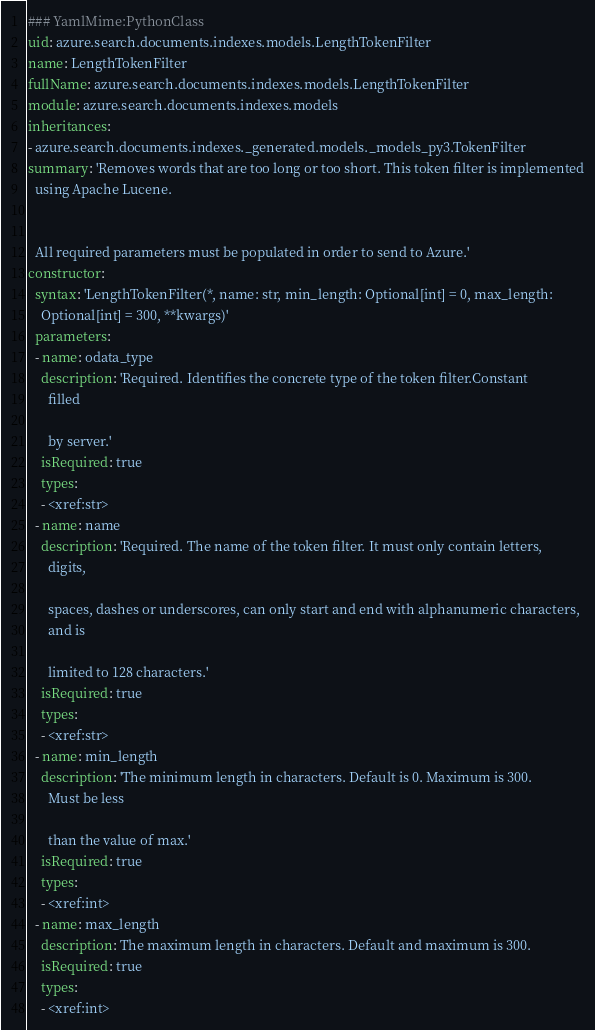Convert code to text. <code><loc_0><loc_0><loc_500><loc_500><_YAML_>### YamlMime:PythonClass
uid: azure.search.documents.indexes.models.LengthTokenFilter
name: LengthTokenFilter
fullName: azure.search.documents.indexes.models.LengthTokenFilter
module: azure.search.documents.indexes.models
inheritances:
- azure.search.documents.indexes._generated.models._models_py3.TokenFilter
summary: 'Removes words that are too long or too short. This token filter is implemented
  using Apache Lucene.


  All required parameters must be populated in order to send to Azure.'
constructor:
  syntax: 'LengthTokenFilter(*, name: str, min_length: Optional[int] = 0, max_length:
    Optional[int] = 300, **kwargs)'
  parameters:
  - name: odata_type
    description: 'Required. Identifies the concrete type of the token filter.Constant
      filled

      by server.'
    isRequired: true
    types:
    - <xref:str>
  - name: name
    description: 'Required. The name of the token filter. It must only contain letters,
      digits,

      spaces, dashes or underscores, can only start and end with alphanumeric characters,
      and is

      limited to 128 characters.'
    isRequired: true
    types:
    - <xref:str>
  - name: min_length
    description: 'The minimum length in characters. Default is 0. Maximum is 300.
      Must be less

      than the value of max.'
    isRequired: true
    types:
    - <xref:int>
  - name: max_length
    description: The maximum length in characters. Default and maximum is 300.
    isRequired: true
    types:
    - <xref:int>
</code> 